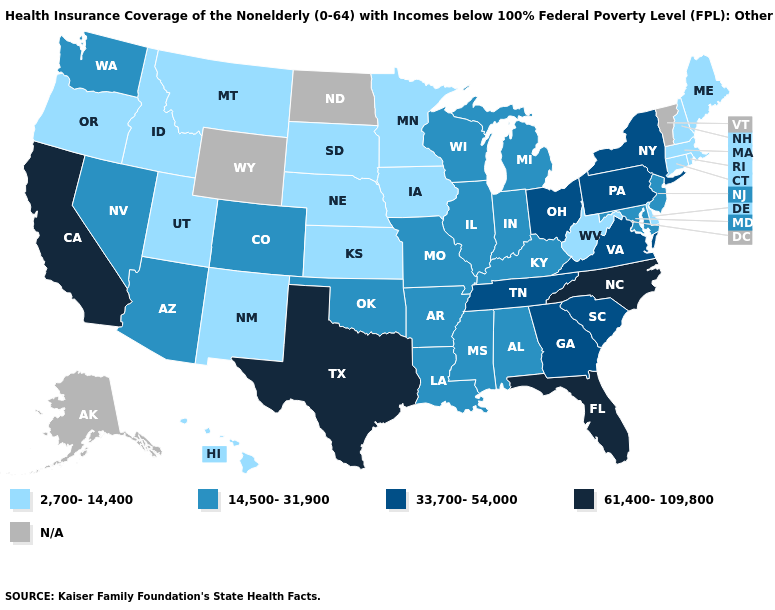Which states have the lowest value in the USA?
Be succinct. Connecticut, Delaware, Hawaii, Idaho, Iowa, Kansas, Maine, Massachusetts, Minnesota, Montana, Nebraska, New Hampshire, New Mexico, Oregon, Rhode Island, South Dakota, Utah, West Virginia. What is the value of Kansas?
Quick response, please. 2,700-14,400. Does Texas have the highest value in the USA?
Be succinct. Yes. Which states hav the highest value in the South?
Answer briefly. Florida, North Carolina, Texas. What is the value of New Hampshire?
Answer briefly. 2,700-14,400. Among the states that border Utah , which have the lowest value?
Be succinct. Idaho, New Mexico. What is the value of Virginia?
Keep it brief. 33,700-54,000. Among the states that border North Carolina , which have the lowest value?
Short answer required. Georgia, South Carolina, Tennessee, Virginia. Does West Virginia have the lowest value in the South?
Be succinct. Yes. What is the value of Louisiana?
Write a very short answer. 14,500-31,900. What is the value of Virginia?
Concise answer only. 33,700-54,000. Name the states that have a value in the range 14,500-31,900?
Keep it brief. Alabama, Arizona, Arkansas, Colorado, Illinois, Indiana, Kentucky, Louisiana, Maryland, Michigan, Mississippi, Missouri, Nevada, New Jersey, Oklahoma, Washington, Wisconsin. What is the highest value in states that border Tennessee?
Keep it brief. 61,400-109,800. Does North Carolina have the highest value in the USA?
Answer briefly. Yes. 